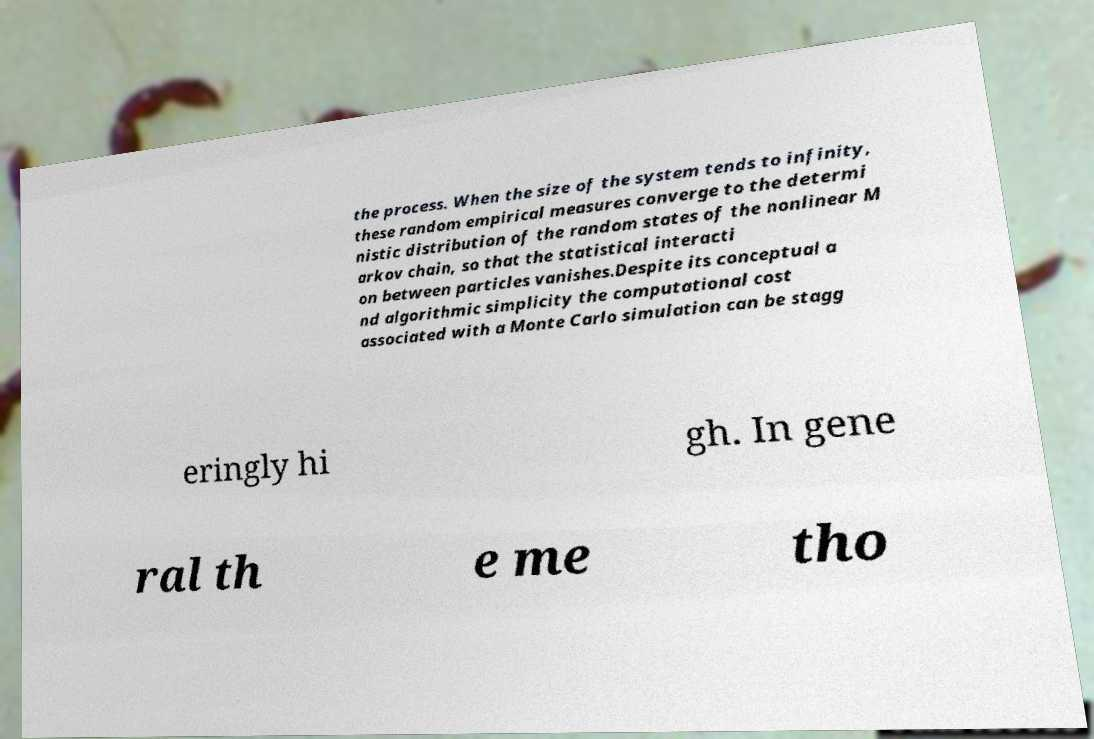I need the written content from this picture converted into text. Can you do that? the process. When the size of the system tends to infinity, these random empirical measures converge to the determi nistic distribution of the random states of the nonlinear M arkov chain, so that the statistical interacti on between particles vanishes.Despite its conceptual a nd algorithmic simplicity the computational cost associated with a Monte Carlo simulation can be stagg eringly hi gh. In gene ral th e me tho 